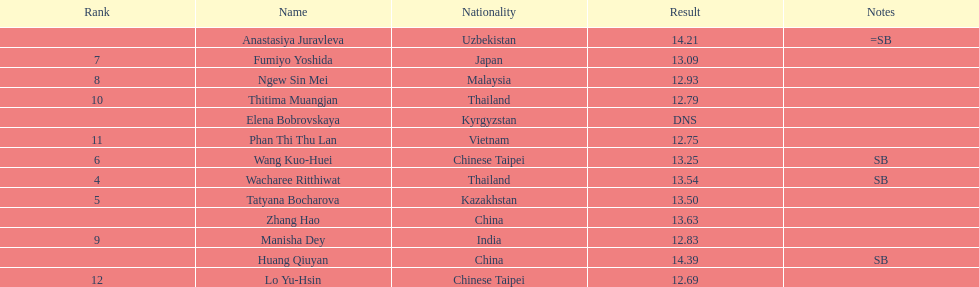What nationality was the woman who won first place? China. 